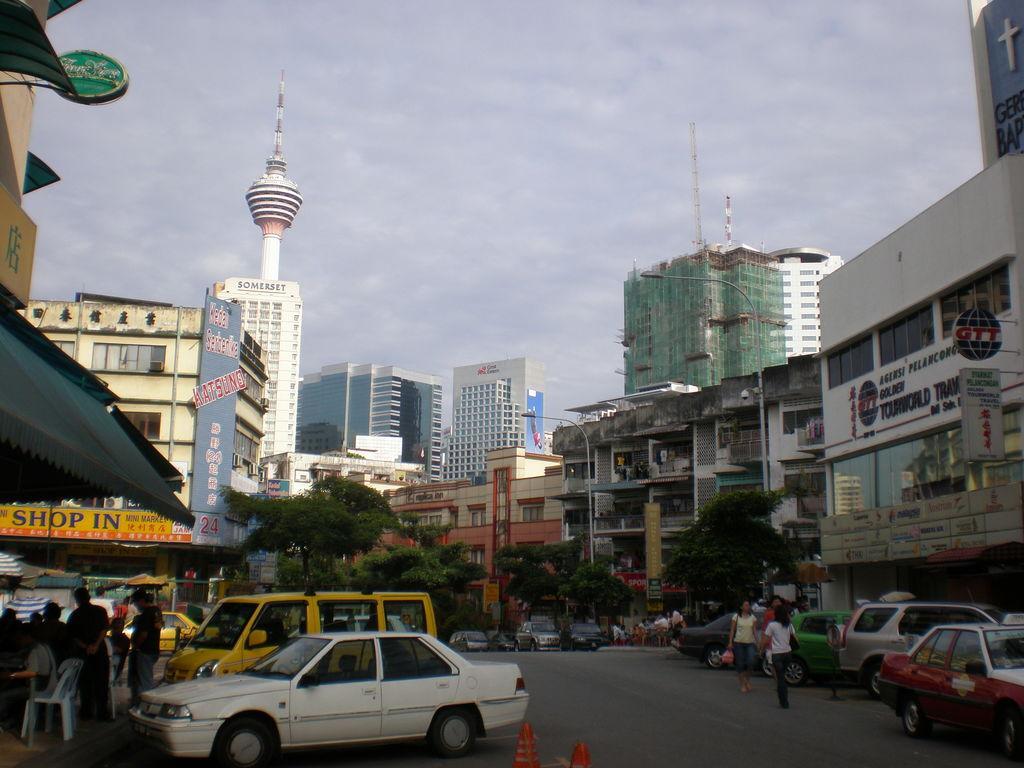In one or two sentences, can you explain what this image depicts? In the foreground of this image, there are vehicles, few persons on the road. On the left, it seems like a shelter under which, there are persons, chair and a table. In the background, there are trees, buildings, skyscraper, sky and the cloud. 